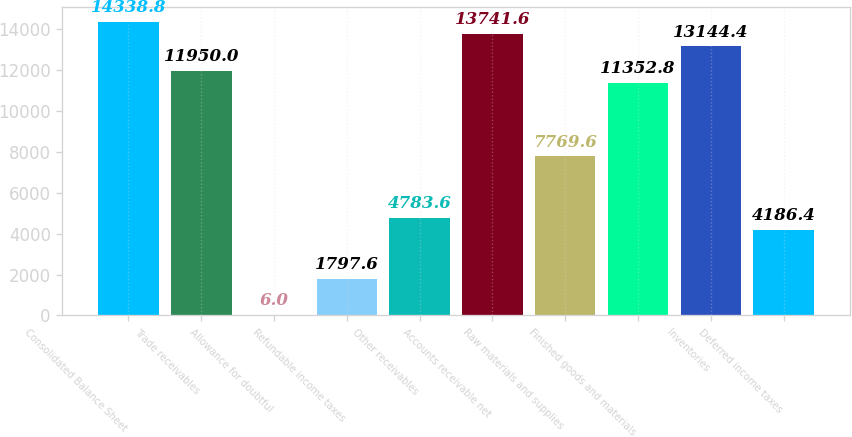Convert chart to OTSL. <chart><loc_0><loc_0><loc_500><loc_500><bar_chart><fcel>Consolidated Balance Sheet<fcel>Trade receivables<fcel>Allowance for doubtful<fcel>Refundable income taxes<fcel>Other receivables<fcel>Accounts receivable net<fcel>Raw materials and supplies<fcel>Finished goods and materials<fcel>Inventories<fcel>Deferred income taxes<nl><fcel>14338.8<fcel>11950<fcel>6<fcel>1797.6<fcel>4783.6<fcel>13741.6<fcel>7769.6<fcel>11352.8<fcel>13144.4<fcel>4186.4<nl></chart> 